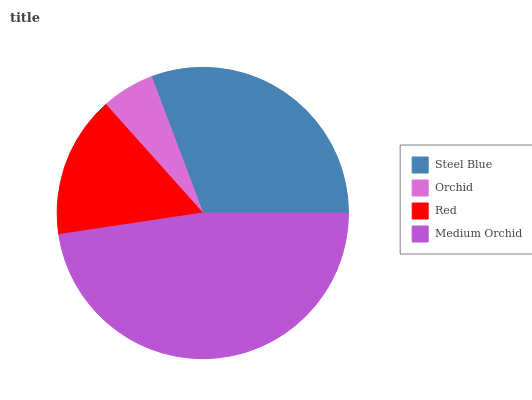Is Orchid the minimum?
Answer yes or no. Yes. Is Medium Orchid the maximum?
Answer yes or no. Yes. Is Red the minimum?
Answer yes or no. No. Is Red the maximum?
Answer yes or no. No. Is Red greater than Orchid?
Answer yes or no. Yes. Is Orchid less than Red?
Answer yes or no. Yes. Is Orchid greater than Red?
Answer yes or no. No. Is Red less than Orchid?
Answer yes or no. No. Is Steel Blue the high median?
Answer yes or no. Yes. Is Red the low median?
Answer yes or no. Yes. Is Medium Orchid the high median?
Answer yes or no. No. Is Steel Blue the low median?
Answer yes or no. No. 